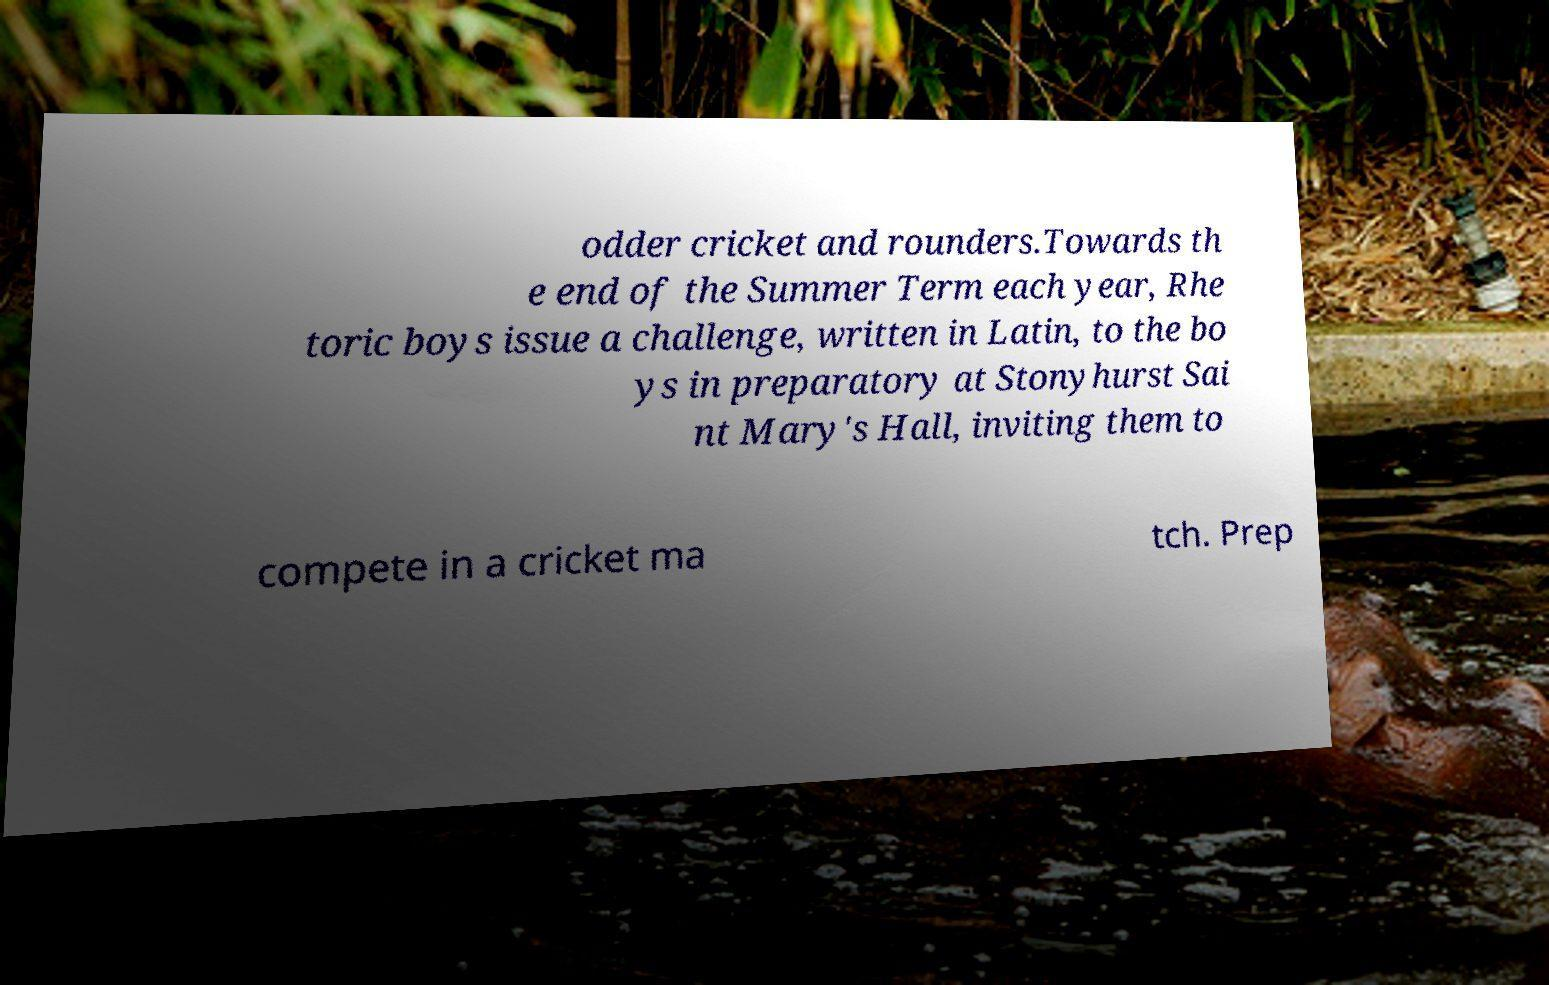Could you assist in decoding the text presented in this image and type it out clearly? odder cricket and rounders.Towards th e end of the Summer Term each year, Rhe toric boys issue a challenge, written in Latin, to the bo ys in preparatory at Stonyhurst Sai nt Mary's Hall, inviting them to compete in a cricket ma tch. Prep 